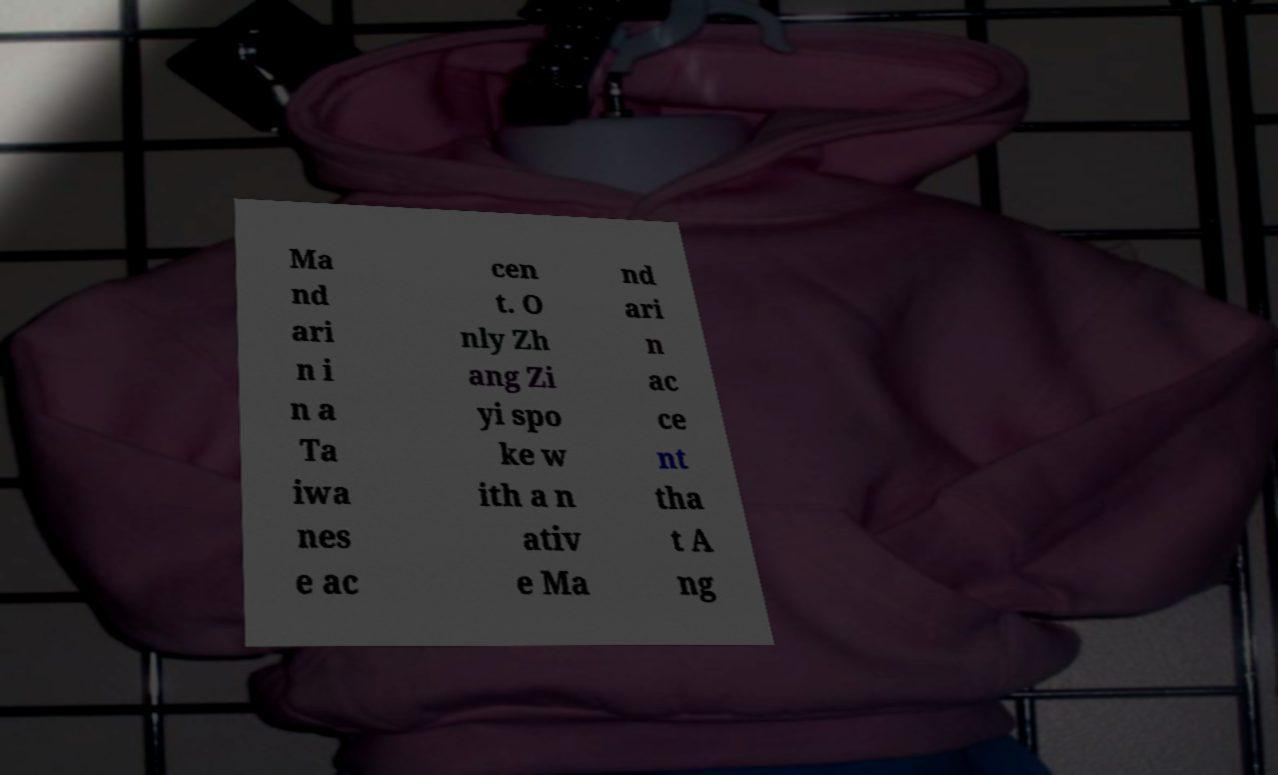For documentation purposes, I need the text within this image transcribed. Could you provide that? Ma nd ari n i n a Ta iwa nes e ac cen t. O nly Zh ang Zi yi spo ke w ith a n ativ e Ma nd ari n ac ce nt tha t A ng 